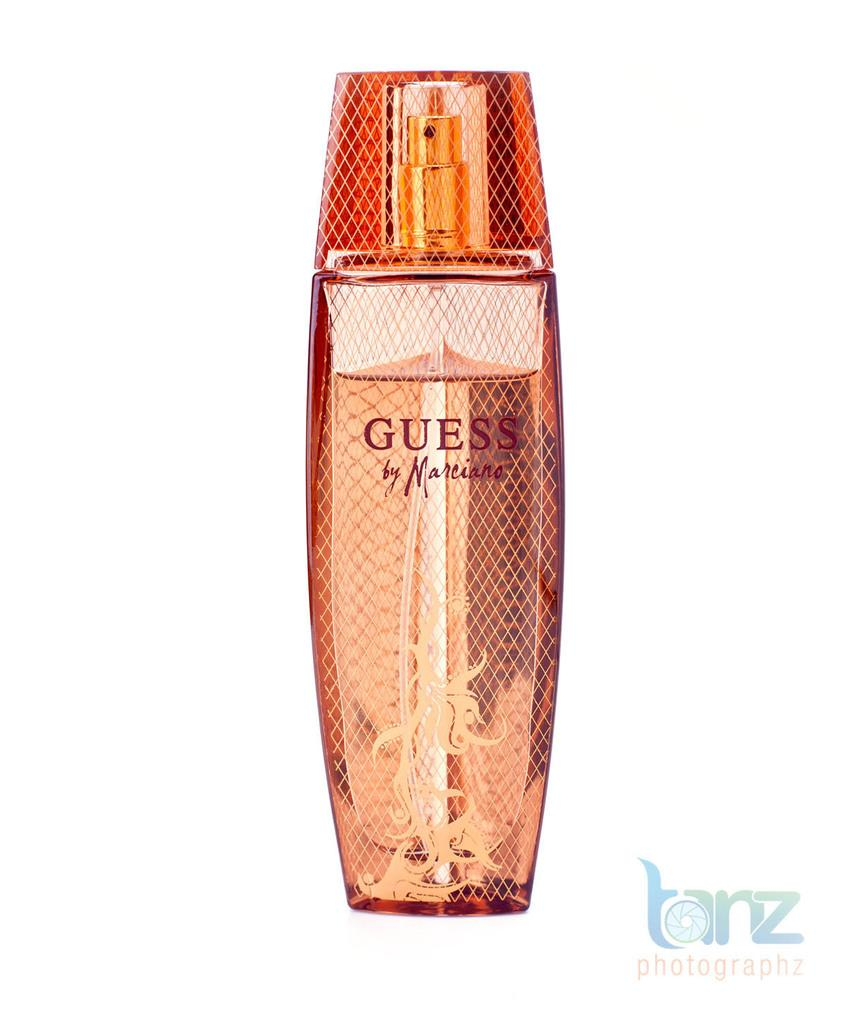<image>
Describe the image concisely. GUESS by Marciano comes in a very attractive bottle. 